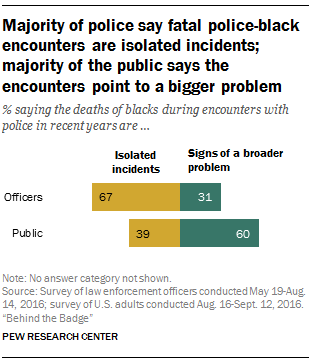Identify some key points in this picture. The color of the bar with a value of 31 is dark green. The sum of the highest and lowest green bar is 91. 